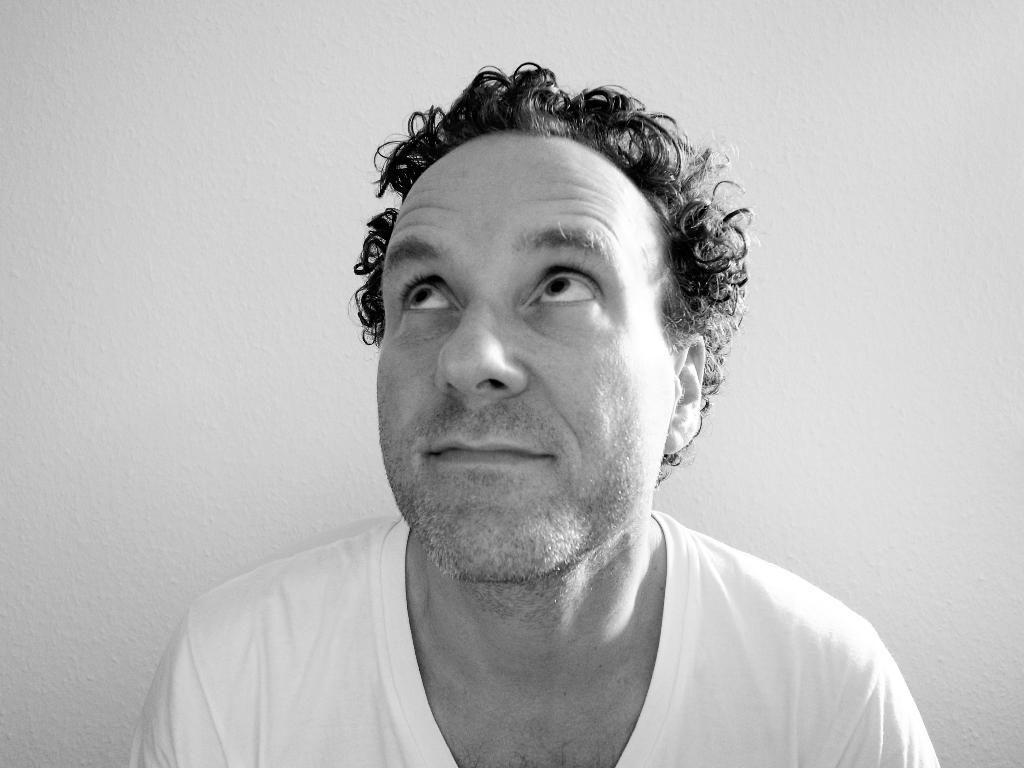Who or what is present in the image? There is a person in the image. What can be seen in the background of the image? There is a wall in the background of the image. What type of mint is growing on the person's head in the image? There is no mint present in the image, and the person's head is not mentioned as having any plants or vegetation. 